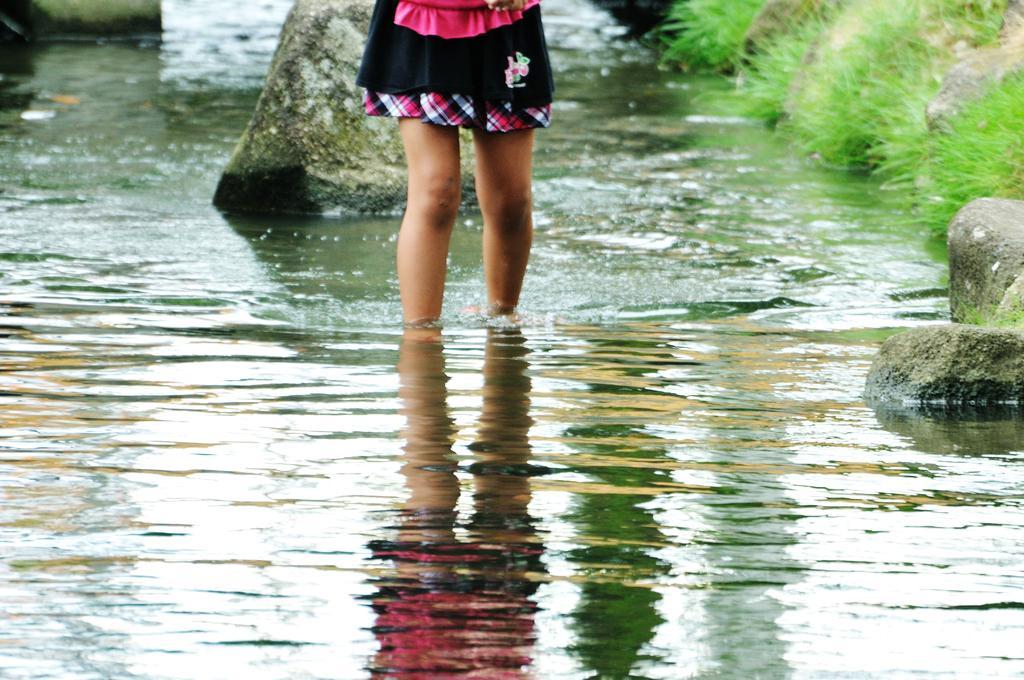How would you summarize this image in a sentence or two? This is the picture of a place where we have some water in which there are some rocks and we can see a girl legs and also some grass to the side. 